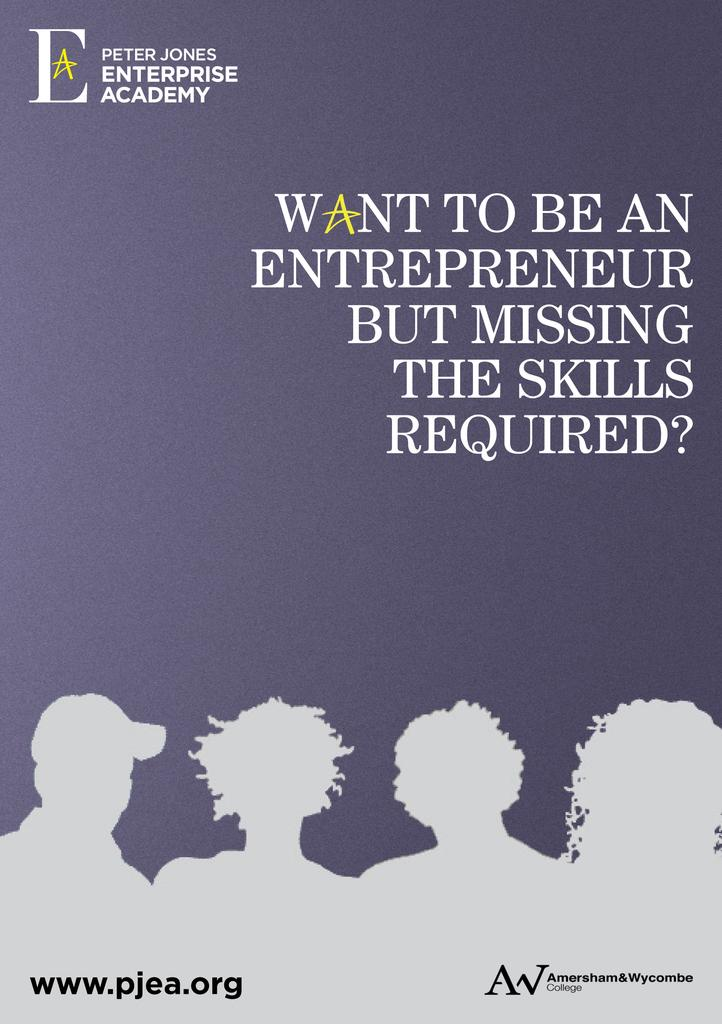Provide a one-sentence caption for the provided image. An advertisement for the Peter Jones Enterprise Academy for aspiring entrepreneurs. 